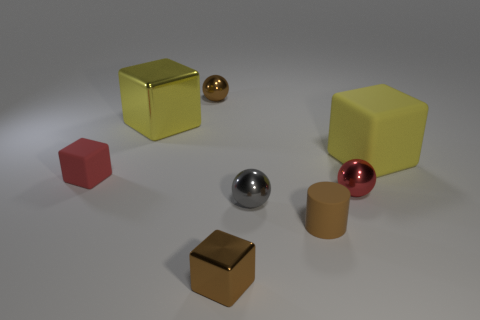Are there an equal number of big metallic blocks in front of the tiny gray thing and small brown matte spheres?
Your response must be concise. Yes. How many large objects are made of the same material as the small gray thing?
Ensure brevity in your answer.  1. What color is the large object that is the same material as the small gray object?
Keep it short and to the point. Yellow. Do the brown metallic block and the yellow block left of the gray metal sphere have the same size?
Your answer should be very brief. No. The small brown matte object is what shape?
Offer a very short reply. Cylinder. What number of tiny shiny spheres are the same color as the rubber cylinder?
Offer a terse response. 1. What is the color of the tiny rubber thing that is the same shape as the large yellow rubber object?
Your response must be concise. Red. There is a tiny metallic object behind the big yellow metal object; what number of red metal spheres are in front of it?
Provide a short and direct response. 1. What number of cubes are either big things or gray objects?
Provide a succinct answer. 2. Are any tiny brown cylinders visible?
Your response must be concise. Yes. 